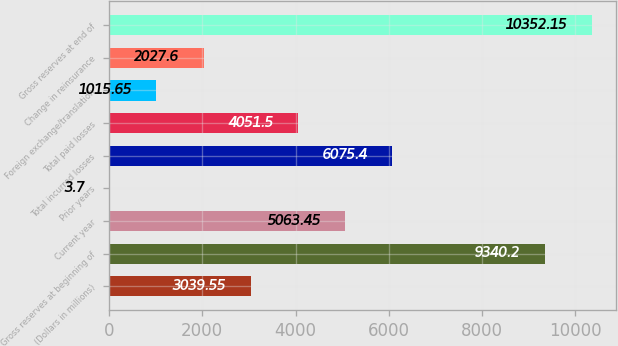Convert chart. <chart><loc_0><loc_0><loc_500><loc_500><bar_chart><fcel>(Dollars in millions)<fcel>Gross reserves at beginning of<fcel>Current year<fcel>Prior years<fcel>Total incurred losses<fcel>Total paid losses<fcel>Foreign exchange/translation<fcel>Change in reinsurance<fcel>Gross reserves at end of<nl><fcel>3039.55<fcel>9340.2<fcel>5063.45<fcel>3.7<fcel>6075.4<fcel>4051.5<fcel>1015.65<fcel>2027.6<fcel>10352.1<nl></chart> 